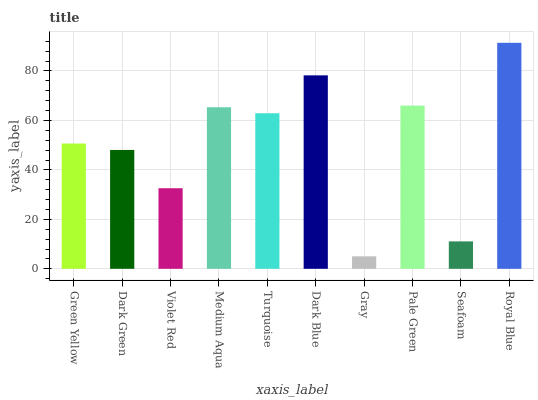Is Dark Green the minimum?
Answer yes or no. No. Is Dark Green the maximum?
Answer yes or no. No. Is Green Yellow greater than Dark Green?
Answer yes or no. Yes. Is Dark Green less than Green Yellow?
Answer yes or no. Yes. Is Dark Green greater than Green Yellow?
Answer yes or no. No. Is Green Yellow less than Dark Green?
Answer yes or no. No. Is Turquoise the high median?
Answer yes or no. Yes. Is Green Yellow the low median?
Answer yes or no. Yes. Is Violet Red the high median?
Answer yes or no. No. Is Violet Red the low median?
Answer yes or no. No. 